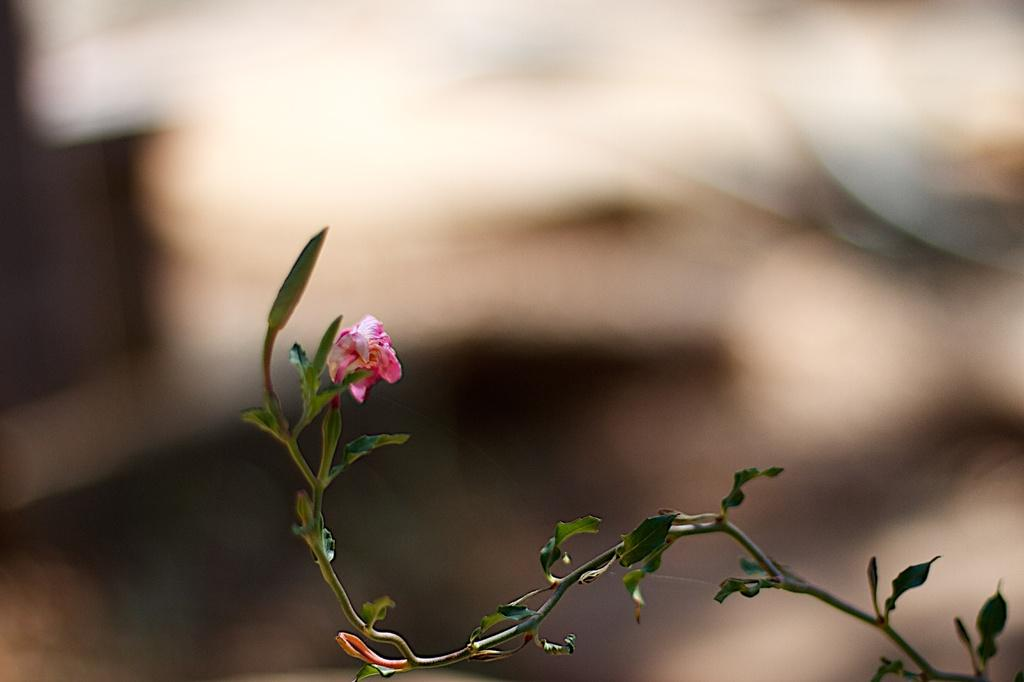What can be seen on the plant in the image? There is a flower on a plant in the image. Can you describe the background of the image? The background of the image is blurred. How many horses are visible in the image? There are no horses present in the image. Is there a tramp in the image for people to jump on? There is no tramp visible in the image. 